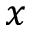Convert formula to latex. <formula><loc_0><loc_0><loc_500><loc_500>x</formula> 